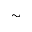<formula> <loc_0><loc_0><loc_500><loc_500>\sim</formula> 